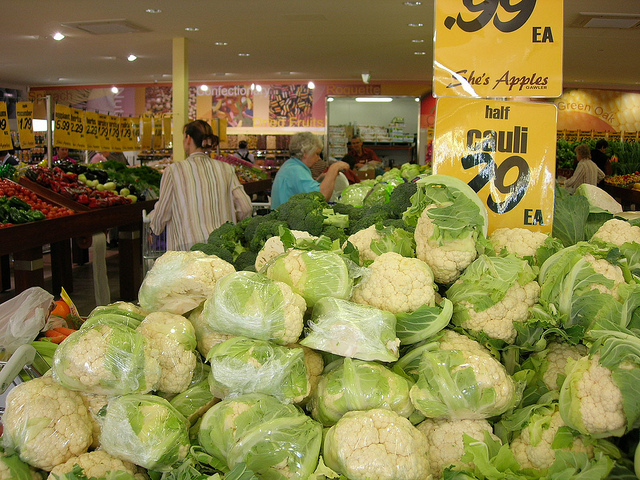What kind of vegetables are predominantly displayed in this image? The image predominantly features cauliflower, which is abundantly displayed in the foreground on top of the green leafy bedding. 